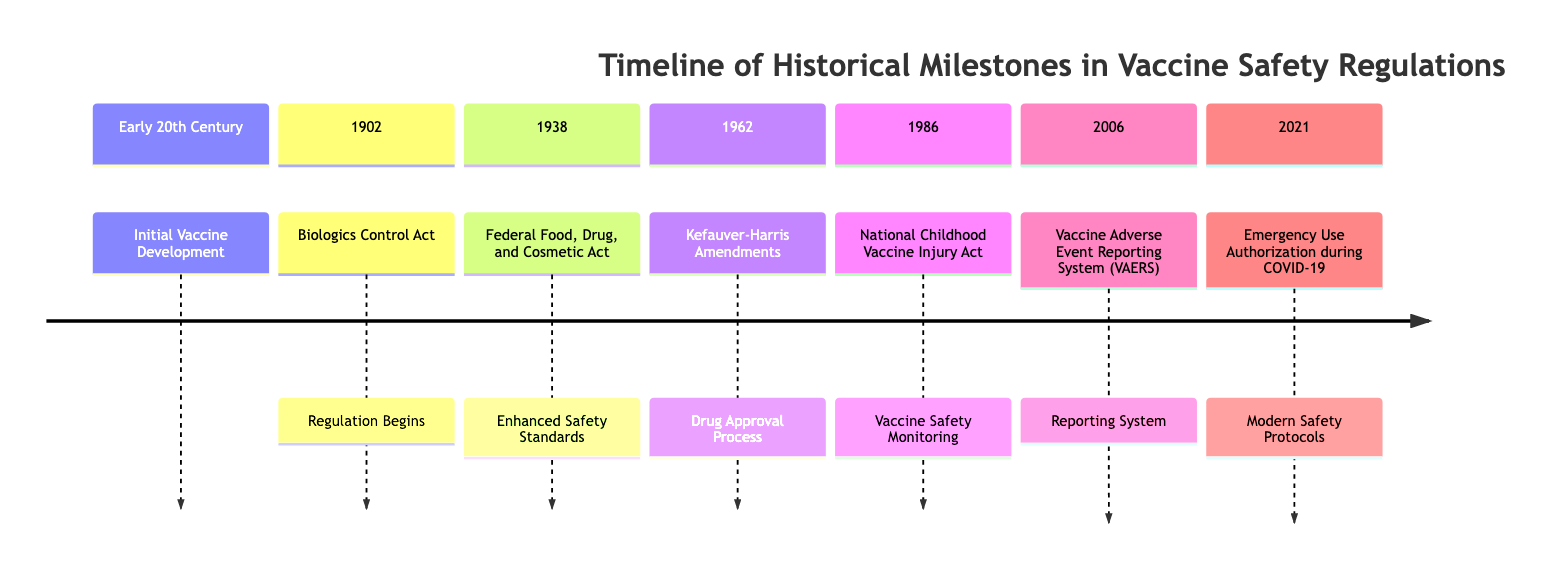What year was the Biologics Control Act established? The diagram indicates that the Biologics Control Act, which marks the beginning of regulation in vaccine safety, occurred in the year 1902.
Answer: 1902 What is the second milestone listed in the timeline? By reviewing the timeline, the second milestone after the initial vaccine development is the "Biologics Control Act" in 1902.
Answer: Biologics Control Act How many milestones are listed in total? The timeline contains seven distinct milestones listed chronologically from the early 20th century to 2021.
Answer: 7 What safety measure was implemented in 1986? Referring to the diagram, the National Childhood Vaccine Injury Act was introduced in 1986, focusing on vaccine safety monitoring.
Answer: Vaccine Safety Monitoring Which milestone introduced modern safety protocols? According to the timeline, the milestone that introduced modern safety protocols was the Emergency Use Authorization during COVID-19 in 2021.
Answer: Emergency Use Authorization during COVID-19 What act enhanced safety standards in 1938? The diagram states that the Federal Food, Drug, and Cosmetic Act, established in 1938, enhanced safety standards for vaccine and drug regulations.
Answer: Federal Food, Drug, and Cosmetic Act Which event occurred right before the establishment of the Vaccine Adverse Event Reporting System? The timeline shows that the National Childhood Vaccine Injury Act, established in 1986, occurred right before the Vaccine Adverse Event Reporting System (VAERS) in 2006.
Answer: National Childhood Vaccine Injury Act What are the two acts mentioned in the 20th century? The diagram indicates that the two acts mentioned in the 20th century are the Biologics Control Act (1902) and the Federal Food, Drug, and Cosmetic Act (1938).
Answer: Biologics Control Act and Federal Food, Drug, and Cosmetic Act 